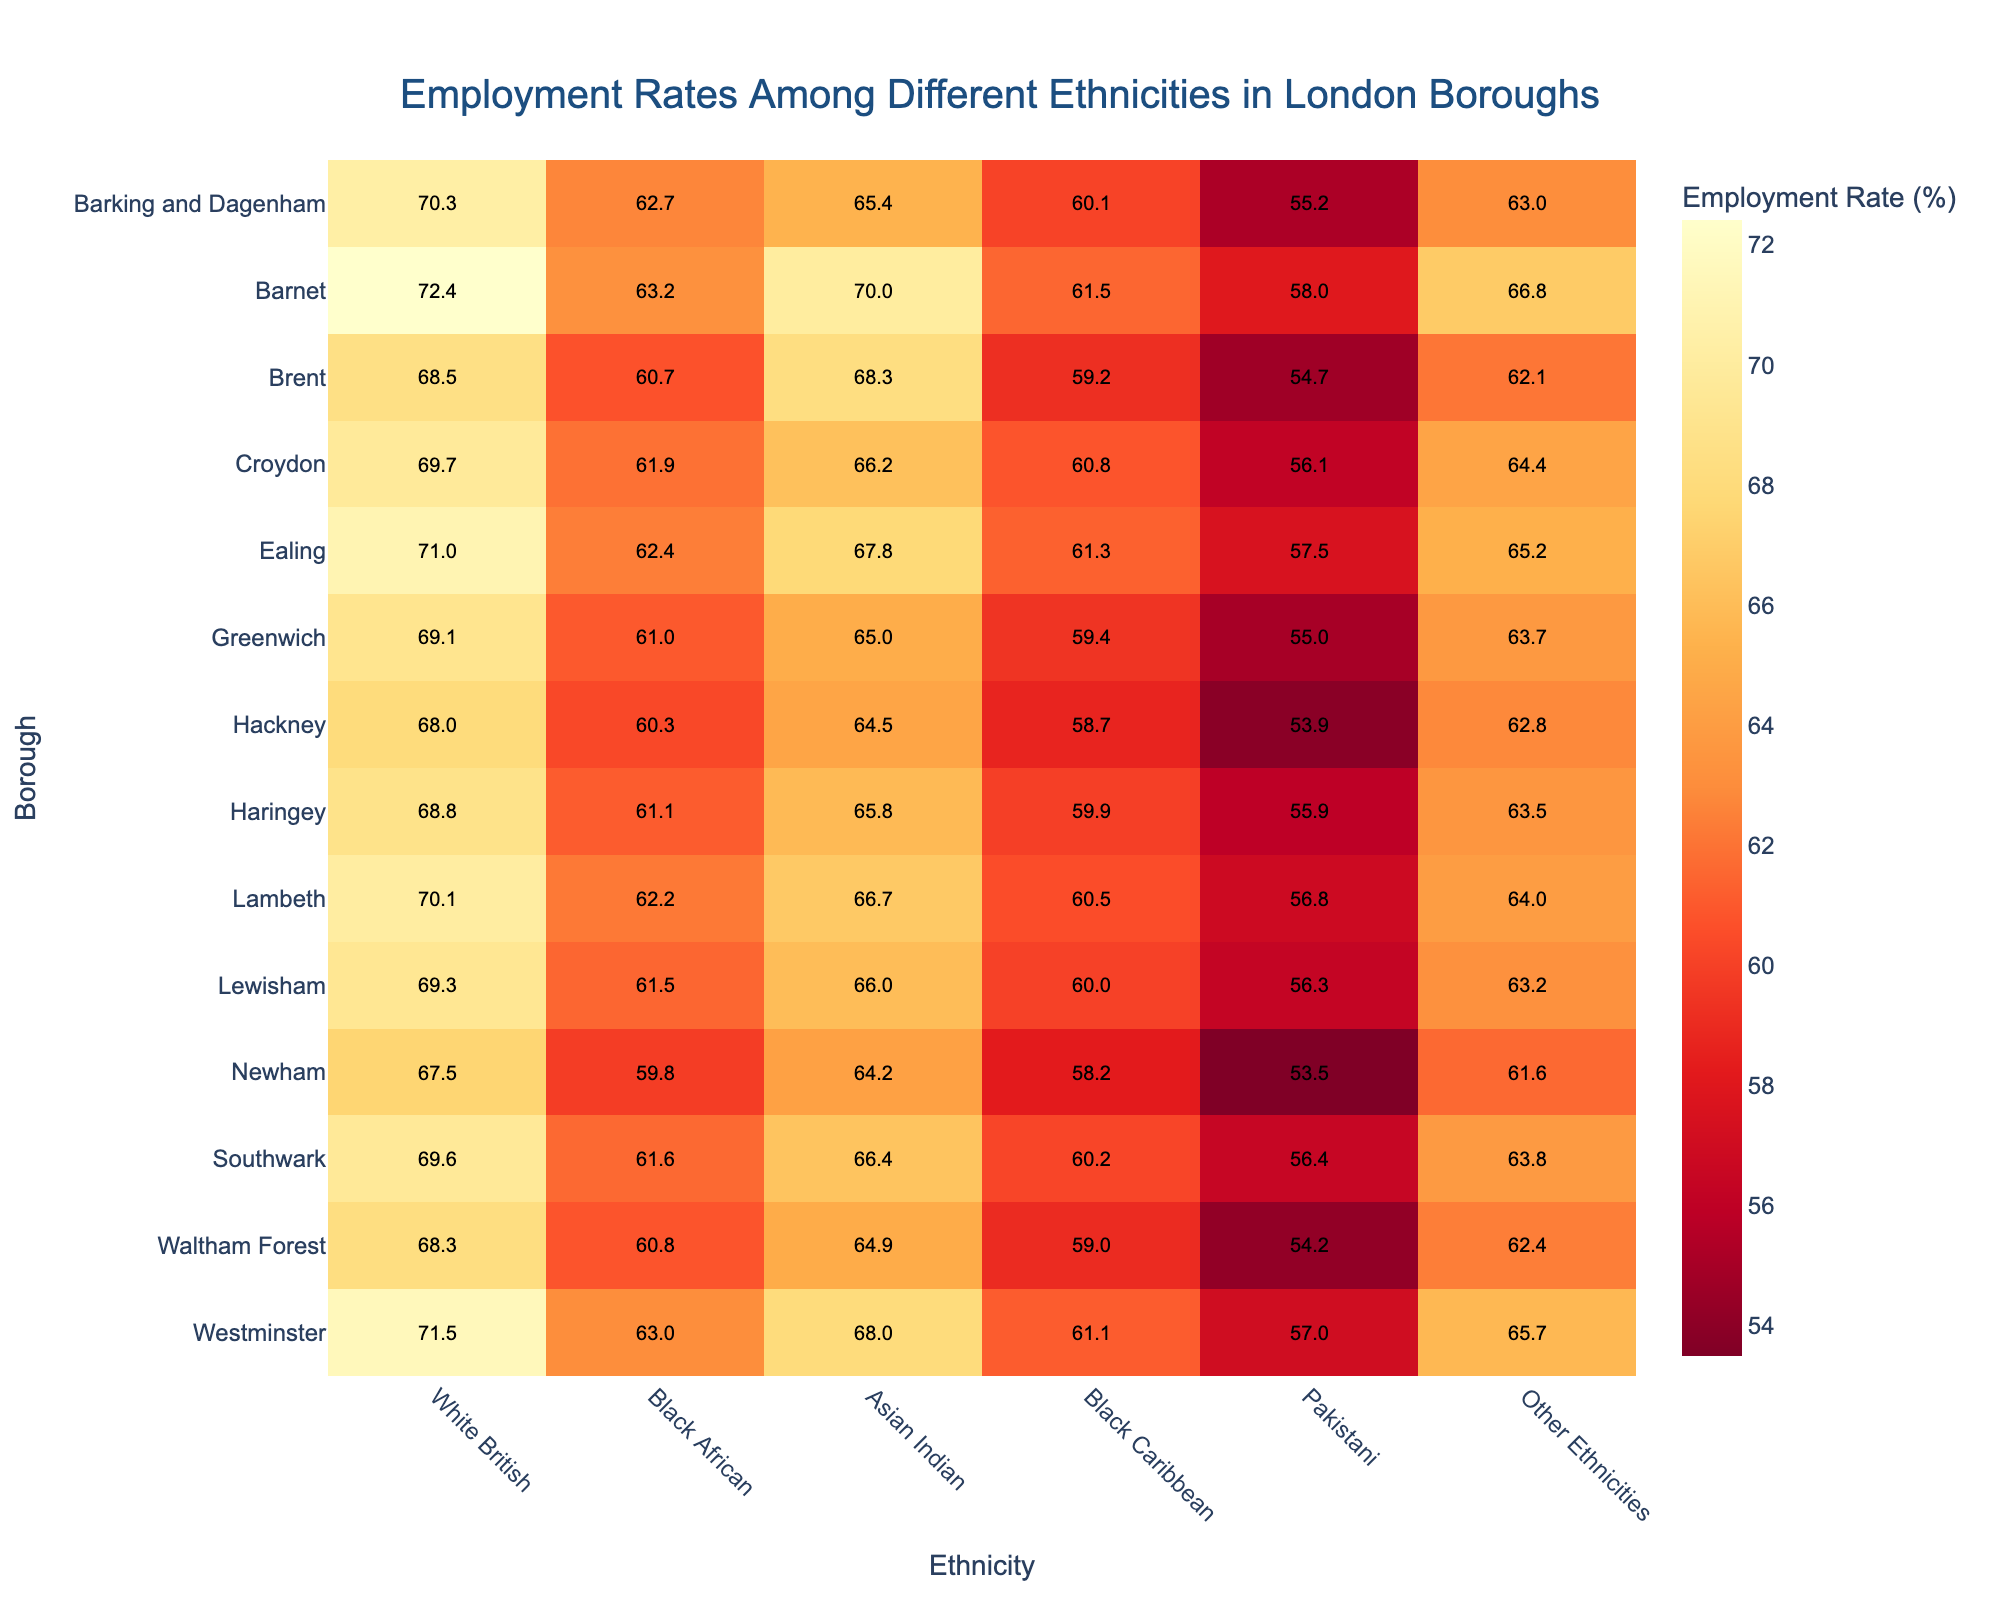What is the title of the heatmap? The title is often located at the top of the heatmap. In this case, the title of the heatmap reads, "Employment Rates Among Different Ethnicities in London Boroughs."
Answer: Employment Rates Among Different Ethnicities in London Boroughs Which borough has the highest employment rate for White British ethnicity? Look across the rows labelled with borough names for the highest employment rate value under the White British column to find that Westminster has the highest employment rate at 71.5%.
Answer: Westminster How does the employment rate for Black African ethnicity in Barnet compare to that in Newham? Identify the employment rates for Black African ethnicity in both Barnet and Newham by looking at their intersection points; Barnet has 63.2%, and Newham has 59.8%. Compare the two values to see that Barnet has a higher employment rate.
Answer: Barnet has a higher rate What is the employment rate for Asian Indian ethnicity in Croydon? Locate the row containing Croydon and find the intersection point under the Asian Indian column, which shows the employment rate to be 66.2%.
Answer: 66.2% Which ethnicity in Brent has the lowest employment rate and what is the rate? Check the employment rates for all ethnicities in Brent, comparing the values: White British (68.5%), Black African (60.7%), Asian Indian (68.3%), Black Caribbean (59.2%), Pakistani (54.7%), and Other Ethnicities (62.1%). The Pakistani ethnicity has the lowest employment rate at 54.7%.
Answer: Pakistani, 54.7% How many boroughs have an employment rate above 66% for White British ethnicity? Check each borough's employment rate for White British ethnicity, count those greater than 66%. These boroughs are Barnet, Ealing, and Westminster.
Answer: 3 Compare the employment rates for Black Caribbean in Lambeth and Southwark. Which one is higher? Examine the intersection points of Black Caribbean for Lambeth (60.5%) and Southwark (60.2%). Lambeth has a slightly higher rate.
Answer: Lambeth What is the range of employment rates for Pakistani ethnicity across all boroughs? Find the minimum and maximum employment rates for Pakistani ethnicity: 53.5% (Newham) and 58% (Barnet). The range is the difference between these values, which is 4.5%.
Answer: 4.5% What is the average employment rate for Asian Indian ethnicity across all boroughs? Add the employment rates for Asian Indian ethnicity across all boroughs and divide by the number of boroughs: (65.4 + 70.0 + 68.3 + 66.2 + 67.8 + 65.0 + 64.5 + 65.8 + 66.7 + 66.0 + 64.2 + 66.4 + 64.9 + 68.0) / 14. The sum is 928.2, and the average is 928.2 / 14 = 66.3%.
Answer: 66.3% Which borough has the most uniform employment rates across different ethnicities (i.e., the smallest range between the highest and lowest rates within the borough)? Calculate the range by subtracting the lowest rate from the highest for each borough. Then find the smallest range. For instance, for Barking and Dagenham, the range is 70.3 - 55.2 = 15.1. Perform this for all boroughs and determine which has the smallest range: Barnes (14.4).
Answer: Barnet 